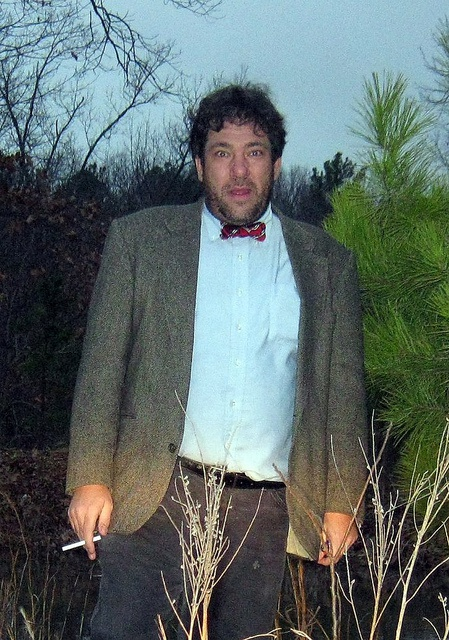Describe the objects in this image and their specific colors. I can see people in lightblue, gray, and black tones and tie in lightblue, black, purple, maroon, and gray tones in this image. 